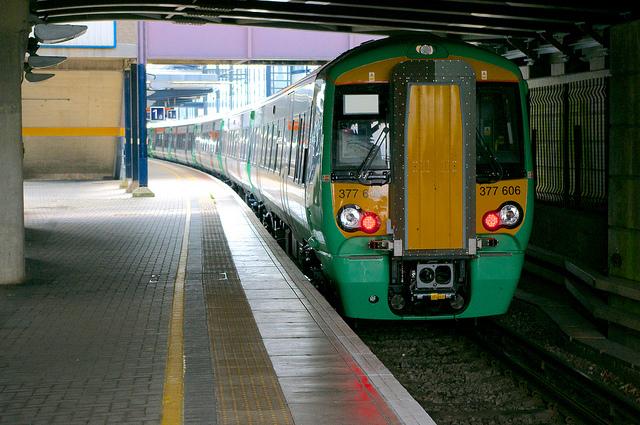What number is on the front of the train?
Be succinct. 377 606. Why is the surface of the train platform so shiny?
Short answer required. Wet. Are there any people here?
Write a very short answer. No. Is the train stopped or moving?
Concise answer only. Moving. Which direction is the train facing?
Quick response, please. Forward. What color lights are shining on the front?
Be succinct. Red. What is the number of the train?
Short answer required. 377 606. Is the train in this image red?
Short answer required. No. What are the numbers on the front of the train?
Keep it brief. 377 606. Are the train doors open?
Keep it brief. No. What is the color of the train?
Answer briefly. Green and yellow. What platform number is this?
Keep it brief. 1. What color is the train?
Write a very short answer. Green and yellow. What color is the photo in?
Short answer required. Color. Is the train in motion?
Write a very short answer. No. Are there any overhead lights on?
Answer briefly. No. What type of transportation is this?
Be succinct. Train. What number route is listed on the bus?
Keep it brief. 377 606. What is the number on the train?
Give a very brief answer. 377 606. Is the train moving?
Short answer required. No. How many trains are pulling into the station?
Be succinct. 1. 